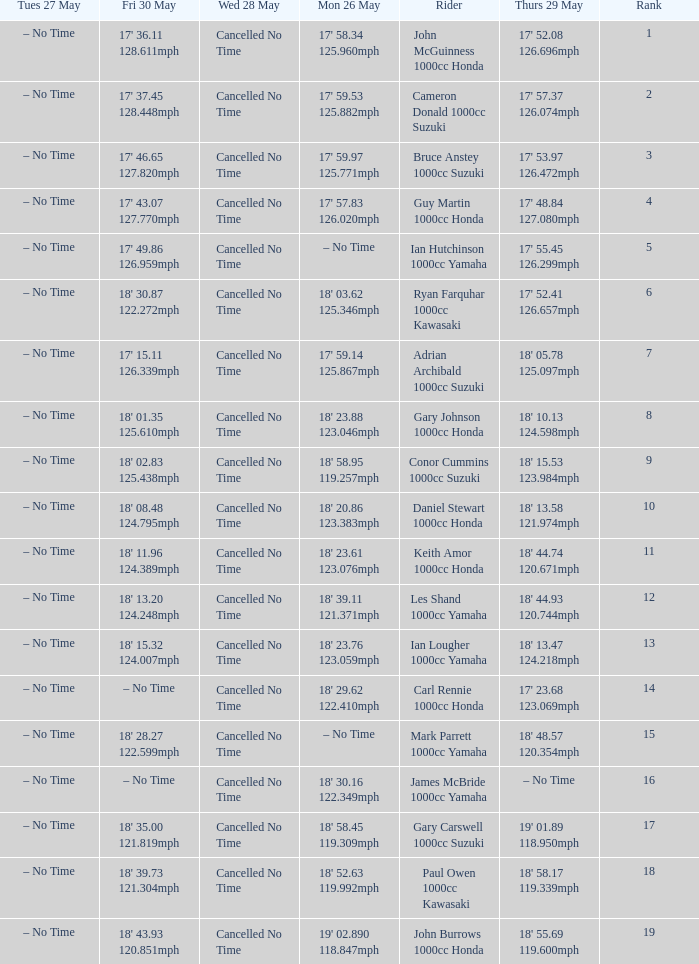What tims is wed may 28 and mon may 26 is 17' 58.34 125.960mph? Cancelled No Time. 